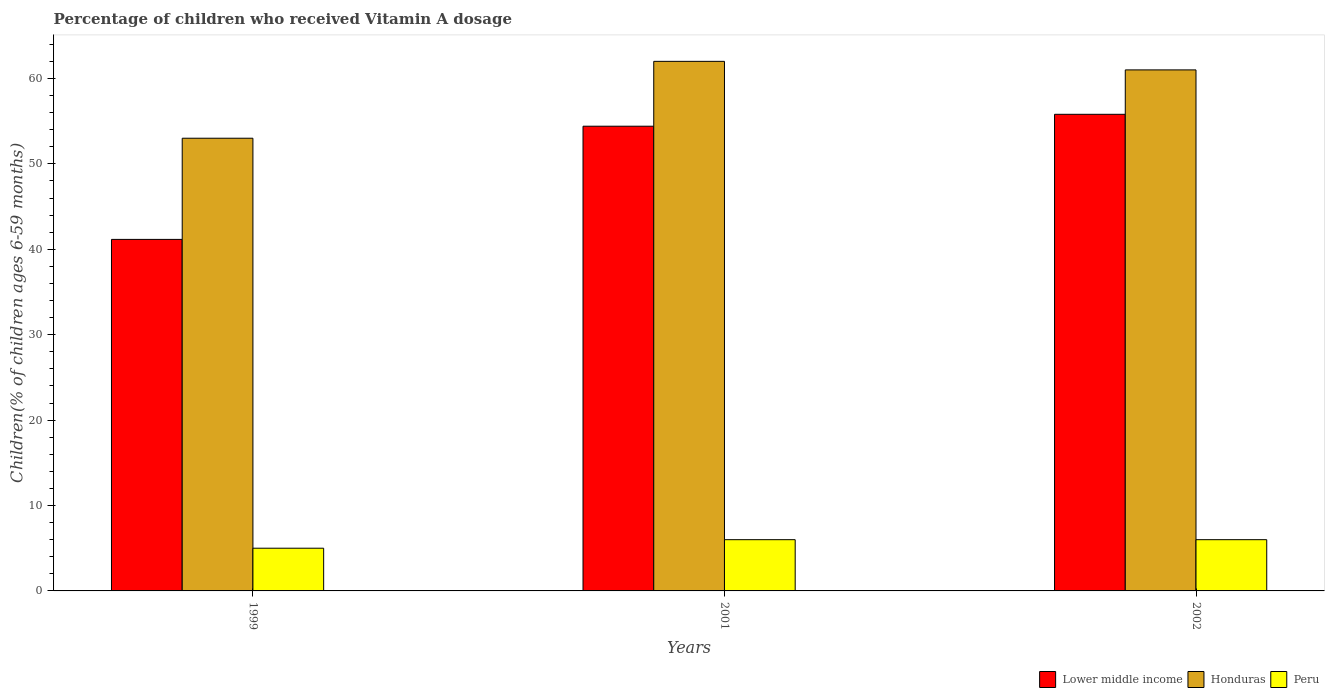How many different coloured bars are there?
Your answer should be very brief. 3. How many groups of bars are there?
Offer a very short reply. 3. Are the number of bars per tick equal to the number of legend labels?
Provide a succinct answer. Yes. How many bars are there on the 2nd tick from the left?
Give a very brief answer. 3. How many bars are there on the 1st tick from the right?
Provide a short and direct response. 3. In how many cases, is the number of bars for a given year not equal to the number of legend labels?
Your response must be concise. 0. What is the percentage of children who received Vitamin A dosage in Peru in 2001?
Give a very brief answer. 6. Across all years, what is the maximum percentage of children who received Vitamin A dosage in Peru?
Make the answer very short. 6. Across all years, what is the minimum percentage of children who received Vitamin A dosage in Honduras?
Your response must be concise. 53. In which year was the percentage of children who received Vitamin A dosage in Lower middle income minimum?
Give a very brief answer. 1999. What is the total percentage of children who received Vitamin A dosage in Peru in the graph?
Offer a terse response. 17. What is the difference between the percentage of children who received Vitamin A dosage in Lower middle income in 1999 and that in 2001?
Keep it short and to the point. -13.25. What is the difference between the percentage of children who received Vitamin A dosage in Lower middle income in 2002 and the percentage of children who received Vitamin A dosage in Honduras in 1999?
Make the answer very short. 2.8. What is the average percentage of children who received Vitamin A dosage in Lower middle income per year?
Provide a short and direct response. 50.45. In the year 2001, what is the difference between the percentage of children who received Vitamin A dosage in Honduras and percentage of children who received Vitamin A dosage in Lower middle income?
Provide a succinct answer. 7.59. In how many years, is the percentage of children who received Vitamin A dosage in Honduras greater than 6 %?
Give a very brief answer. 3. What is the ratio of the percentage of children who received Vitamin A dosage in Peru in 1999 to that in 2002?
Your response must be concise. 0.83. What is the difference between the highest and the second highest percentage of children who received Vitamin A dosage in Lower middle income?
Provide a succinct answer. 1.39. In how many years, is the percentage of children who received Vitamin A dosage in Lower middle income greater than the average percentage of children who received Vitamin A dosage in Lower middle income taken over all years?
Ensure brevity in your answer.  2. What does the 1st bar from the left in 1999 represents?
Provide a succinct answer. Lower middle income. Is it the case that in every year, the sum of the percentage of children who received Vitamin A dosage in Peru and percentage of children who received Vitamin A dosage in Honduras is greater than the percentage of children who received Vitamin A dosage in Lower middle income?
Provide a succinct answer. Yes. How many years are there in the graph?
Provide a short and direct response. 3. What is the difference between two consecutive major ticks on the Y-axis?
Ensure brevity in your answer.  10. Are the values on the major ticks of Y-axis written in scientific E-notation?
Your response must be concise. No. How many legend labels are there?
Offer a very short reply. 3. What is the title of the graph?
Your response must be concise. Percentage of children who received Vitamin A dosage. What is the label or title of the Y-axis?
Ensure brevity in your answer.  Children(% of children ages 6-59 months). What is the Children(% of children ages 6-59 months) of Lower middle income in 1999?
Provide a succinct answer. 41.16. What is the Children(% of children ages 6-59 months) of Honduras in 1999?
Keep it short and to the point. 53. What is the Children(% of children ages 6-59 months) in Lower middle income in 2001?
Your response must be concise. 54.41. What is the Children(% of children ages 6-59 months) of Lower middle income in 2002?
Offer a very short reply. 55.8. What is the Children(% of children ages 6-59 months) in Peru in 2002?
Give a very brief answer. 6. Across all years, what is the maximum Children(% of children ages 6-59 months) of Lower middle income?
Give a very brief answer. 55.8. Across all years, what is the maximum Children(% of children ages 6-59 months) in Honduras?
Give a very brief answer. 62. Across all years, what is the maximum Children(% of children ages 6-59 months) in Peru?
Your response must be concise. 6. Across all years, what is the minimum Children(% of children ages 6-59 months) in Lower middle income?
Make the answer very short. 41.16. Across all years, what is the minimum Children(% of children ages 6-59 months) in Honduras?
Provide a short and direct response. 53. What is the total Children(% of children ages 6-59 months) of Lower middle income in the graph?
Make the answer very short. 151.36. What is the total Children(% of children ages 6-59 months) of Honduras in the graph?
Keep it short and to the point. 176. What is the difference between the Children(% of children ages 6-59 months) of Lower middle income in 1999 and that in 2001?
Provide a succinct answer. -13.25. What is the difference between the Children(% of children ages 6-59 months) in Peru in 1999 and that in 2001?
Make the answer very short. -1. What is the difference between the Children(% of children ages 6-59 months) in Lower middle income in 1999 and that in 2002?
Make the answer very short. -14.64. What is the difference between the Children(% of children ages 6-59 months) in Honduras in 1999 and that in 2002?
Your answer should be compact. -8. What is the difference between the Children(% of children ages 6-59 months) in Lower middle income in 2001 and that in 2002?
Ensure brevity in your answer.  -1.39. What is the difference between the Children(% of children ages 6-59 months) of Honduras in 2001 and that in 2002?
Make the answer very short. 1. What is the difference between the Children(% of children ages 6-59 months) of Lower middle income in 1999 and the Children(% of children ages 6-59 months) of Honduras in 2001?
Make the answer very short. -20.84. What is the difference between the Children(% of children ages 6-59 months) in Lower middle income in 1999 and the Children(% of children ages 6-59 months) in Peru in 2001?
Ensure brevity in your answer.  35.16. What is the difference between the Children(% of children ages 6-59 months) in Lower middle income in 1999 and the Children(% of children ages 6-59 months) in Honduras in 2002?
Provide a short and direct response. -19.84. What is the difference between the Children(% of children ages 6-59 months) of Lower middle income in 1999 and the Children(% of children ages 6-59 months) of Peru in 2002?
Your answer should be compact. 35.16. What is the difference between the Children(% of children ages 6-59 months) in Honduras in 1999 and the Children(% of children ages 6-59 months) in Peru in 2002?
Provide a succinct answer. 47. What is the difference between the Children(% of children ages 6-59 months) of Lower middle income in 2001 and the Children(% of children ages 6-59 months) of Honduras in 2002?
Ensure brevity in your answer.  -6.59. What is the difference between the Children(% of children ages 6-59 months) in Lower middle income in 2001 and the Children(% of children ages 6-59 months) in Peru in 2002?
Make the answer very short. 48.41. What is the difference between the Children(% of children ages 6-59 months) of Honduras in 2001 and the Children(% of children ages 6-59 months) of Peru in 2002?
Your answer should be compact. 56. What is the average Children(% of children ages 6-59 months) of Lower middle income per year?
Ensure brevity in your answer.  50.45. What is the average Children(% of children ages 6-59 months) in Honduras per year?
Your response must be concise. 58.67. What is the average Children(% of children ages 6-59 months) in Peru per year?
Your answer should be very brief. 5.67. In the year 1999, what is the difference between the Children(% of children ages 6-59 months) in Lower middle income and Children(% of children ages 6-59 months) in Honduras?
Offer a very short reply. -11.84. In the year 1999, what is the difference between the Children(% of children ages 6-59 months) of Lower middle income and Children(% of children ages 6-59 months) of Peru?
Keep it short and to the point. 36.16. In the year 1999, what is the difference between the Children(% of children ages 6-59 months) of Honduras and Children(% of children ages 6-59 months) of Peru?
Provide a succinct answer. 48. In the year 2001, what is the difference between the Children(% of children ages 6-59 months) in Lower middle income and Children(% of children ages 6-59 months) in Honduras?
Offer a terse response. -7.59. In the year 2001, what is the difference between the Children(% of children ages 6-59 months) in Lower middle income and Children(% of children ages 6-59 months) in Peru?
Offer a very short reply. 48.41. In the year 2001, what is the difference between the Children(% of children ages 6-59 months) of Honduras and Children(% of children ages 6-59 months) of Peru?
Your answer should be very brief. 56. In the year 2002, what is the difference between the Children(% of children ages 6-59 months) in Lower middle income and Children(% of children ages 6-59 months) in Honduras?
Make the answer very short. -5.2. In the year 2002, what is the difference between the Children(% of children ages 6-59 months) of Lower middle income and Children(% of children ages 6-59 months) of Peru?
Your answer should be very brief. 49.8. What is the ratio of the Children(% of children ages 6-59 months) of Lower middle income in 1999 to that in 2001?
Ensure brevity in your answer.  0.76. What is the ratio of the Children(% of children ages 6-59 months) in Honduras in 1999 to that in 2001?
Your answer should be compact. 0.85. What is the ratio of the Children(% of children ages 6-59 months) of Peru in 1999 to that in 2001?
Offer a very short reply. 0.83. What is the ratio of the Children(% of children ages 6-59 months) in Lower middle income in 1999 to that in 2002?
Your answer should be very brief. 0.74. What is the ratio of the Children(% of children ages 6-59 months) of Honduras in 1999 to that in 2002?
Your response must be concise. 0.87. What is the ratio of the Children(% of children ages 6-59 months) in Honduras in 2001 to that in 2002?
Provide a short and direct response. 1.02. What is the difference between the highest and the second highest Children(% of children ages 6-59 months) in Lower middle income?
Keep it short and to the point. 1.39. What is the difference between the highest and the second highest Children(% of children ages 6-59 months) of Honduras?
Keep it short and to the point. 1. What is the difference between the highest and the lowest Children(% of children ages 6-59 months) in Lower middle income?
Your response must be concise. 14.64. What is the difference between the highest and the lowest Children(% of children ages 6-59 months) of Honduras?
Keep it short and to the point. 9. What is the difference between the highest and the lowest Children(% of children ages 6-59 months) in Peru?
Ensure brevity in your answer.  1. 